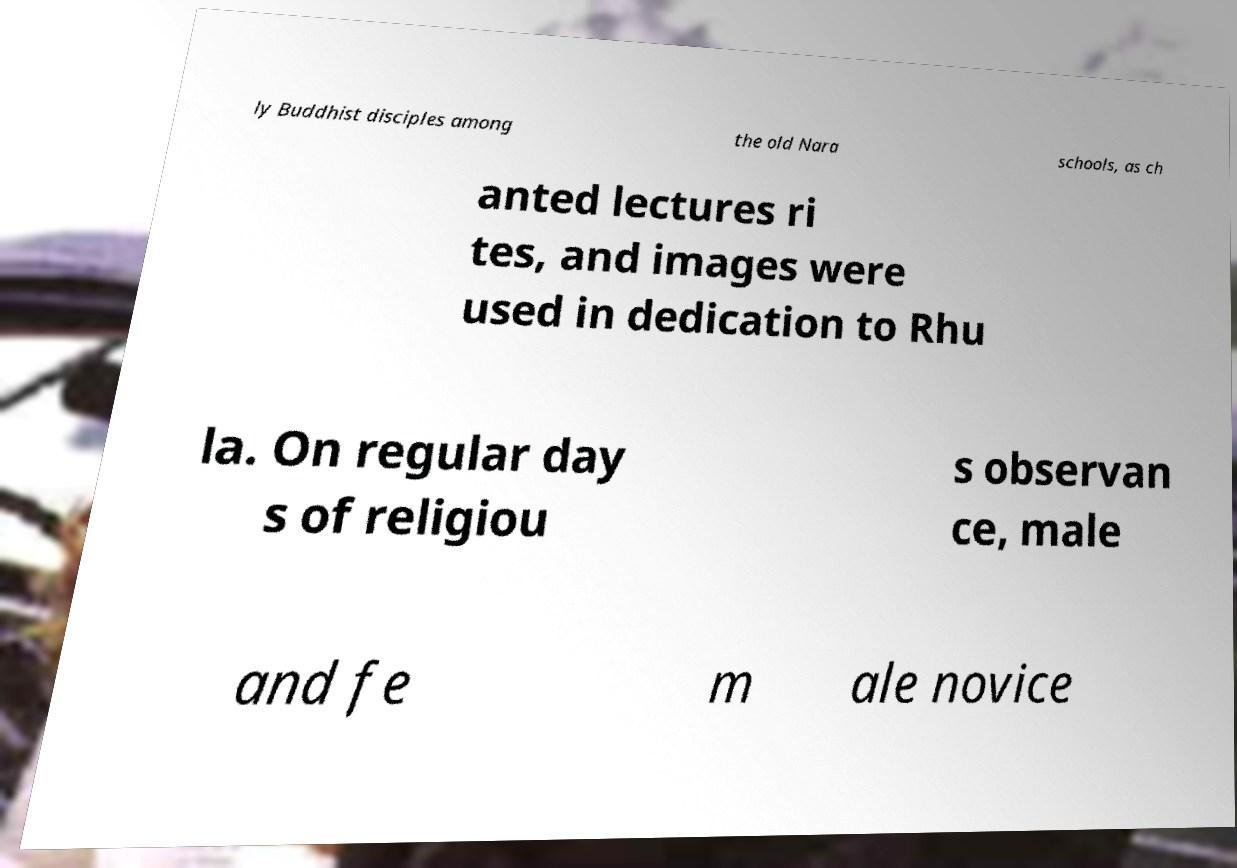There's text embedded in this image that I need extracted. Can you transcribe it verbatim? ly Buddhist disciples among the old Nara schools, as ch anted lectures ri tes, and images were used in dedication to Rhu la. On regular day s of religiou s observan ce, male and fe m ale novice 